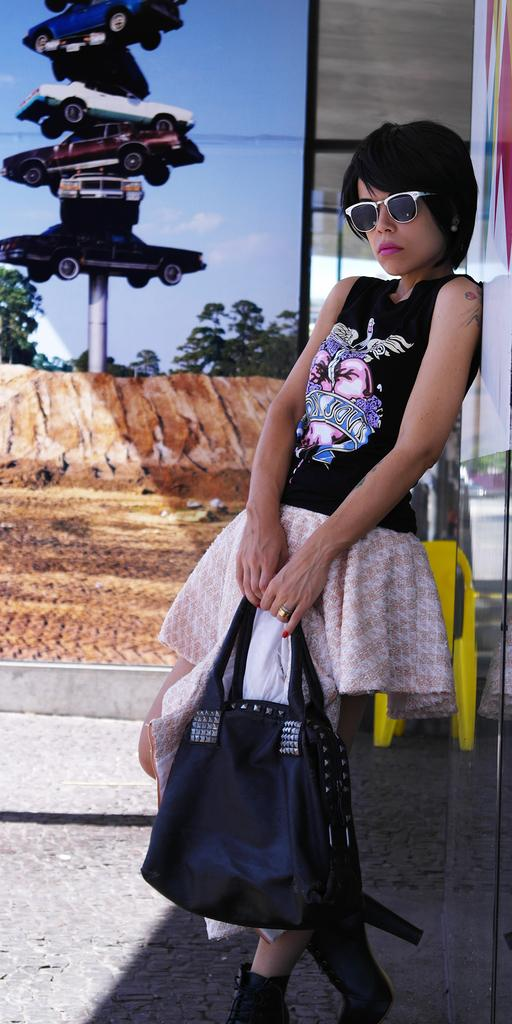Who is present in the image? There is a woman in the image. What is the woman wearing? The woman is wearing a black dress and goggles. What is the woman holding in the image? The woman is holding a bag. What can be seen on the pole in the image? There are cars on a pole in the image. What is visible in the distance in the image? There are trees visible in the distance. What is on the wall in the image? There is a poster on a wall in the image. What type of board is the scarecrow riding in the image? There is no scarecrow or board present in the image. What is the woman doing with her arm in the image? The image does not show the woman's arm or any specific action with it. 